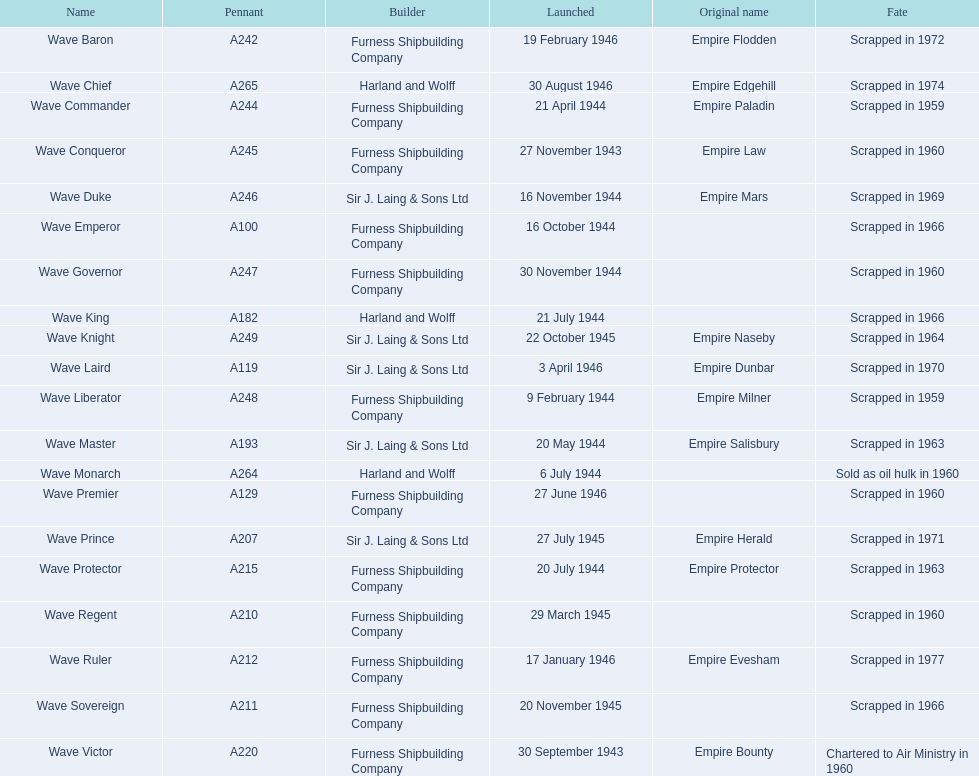What shipmakers released ships in november of any given year? Furness Shipbuilding Company, Sir J. Laing & Sons Ltd, Furness Shipbuilding Company, Furness Shipbuilding Company. Which shipmakers' ships underwent original name changes before demolition? Furness Shipbuilding Company, Sir J. Laing & Sons Ltd. What was the title of the ship that was developed in november and experienced name alteration before demolition, merely 12 years after its release? Wave Conqueror. 